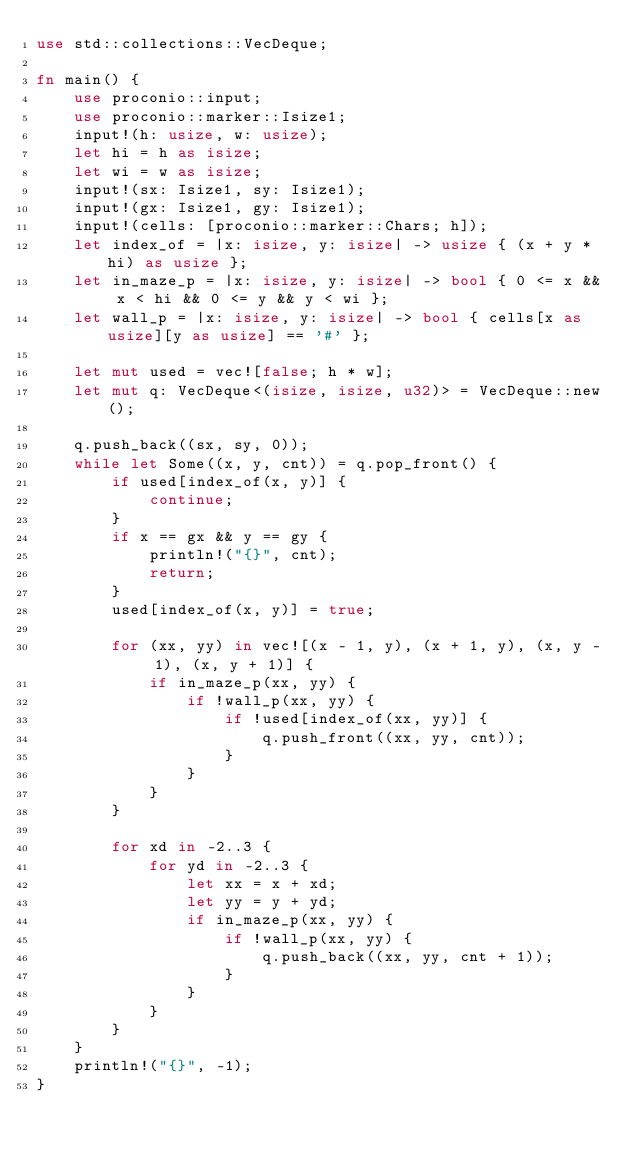<code> <loc_0><loc_0><loc_500><loc_500><_Rust_>use std::collections::VecDeque;

fn main() {
    use proconio::input;
    use proconio::marker::Isize1;
    input!(h: usize, w: usize);
    let hi = h as isize;
    let wi = w as isize;
    input!(sx: Isize1, sy: Isize1);
    input!(gx: Isize1, gy: Isize1);
    input!(cells: [proconio::marker::Chars; h]);
    let index_of = |x: isize, y: isize| -> usize { (x + y * hi) as usize };
    let in_maze_p = |x: isize, y: isize| -> bool { 0 <= x && x < hi && 0 <= y && y < wi };
    let wall_p = |x: isize, y: isize| -> bool { cells[x as usize][y as usize] == '#' };

    let mut used = vec![false; h * w];
    let mut q: VecDeque<(isize, isize, u32)> = VecDeque::new();

    q.push_back((sx, sy, 0));
    while let Some((x, y, cnt)) = q.pop_front() {
        if used[index_of(x, y)] {
            continue;
        }
        if x == gx && y == gy {
            println!("{}", cnt);
            return;
        }
        used[index_of(x, y)] = true;

        for (xx, yy) in vec![(x - 1, y), (x + 1, y), (x, y - 1), (x, y + 1)] {
            if in_maze_p(xx, yy) {
                if !wall_p(xx, yy) {
                    if !used[index_of(xx, yy)] {
                        q.push_front((xx, yy, cnt));
                    }
                }
            }
        }

        for xd in -2..3 {
            for yd in -2..3 {
                let xx = x + xd;
                let yy = y + yd;
                if in_maze_p(xx, yy) {
                    if !wall_p(xx, yy) {
                        q.push_back((xx, yy, cnt + 1));
                    }
                }
            }
        }
    }
    println!("{}", -1);
}
</code> 